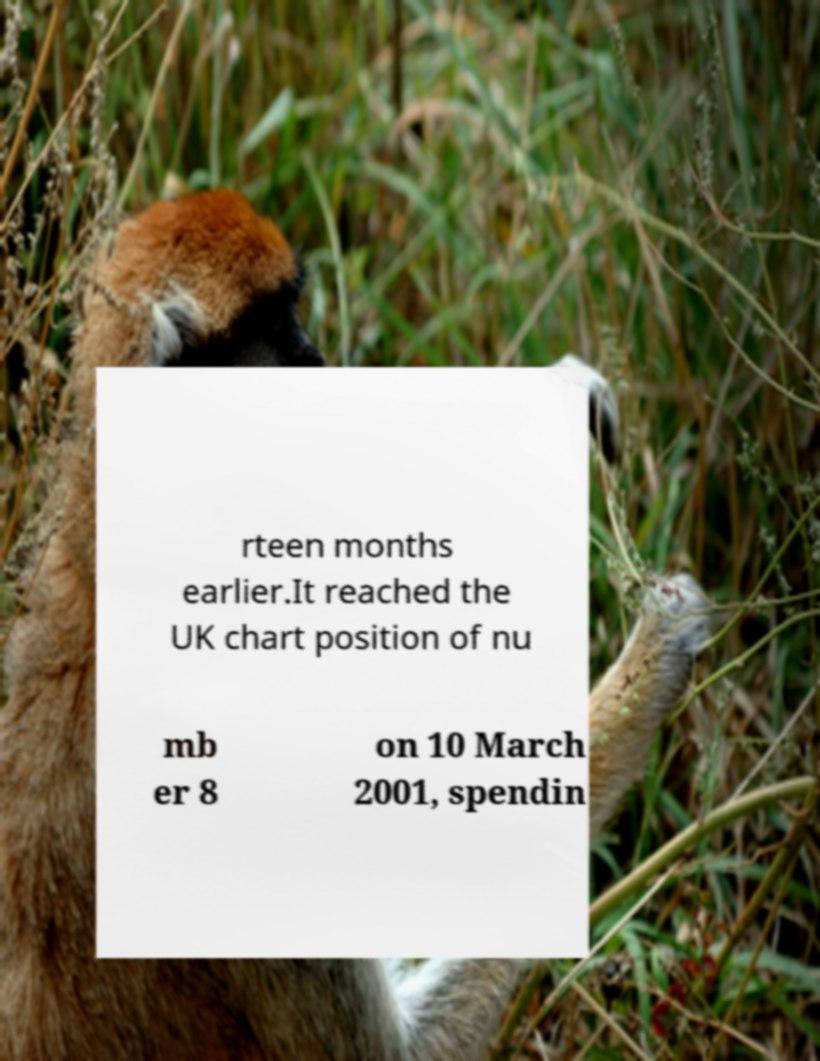Could you assist in decoding the text presented in this image and type it out clearly? rteen months earlier.It reached the UK chart position of nu mb er 8 on 10 March 2001, spendin 